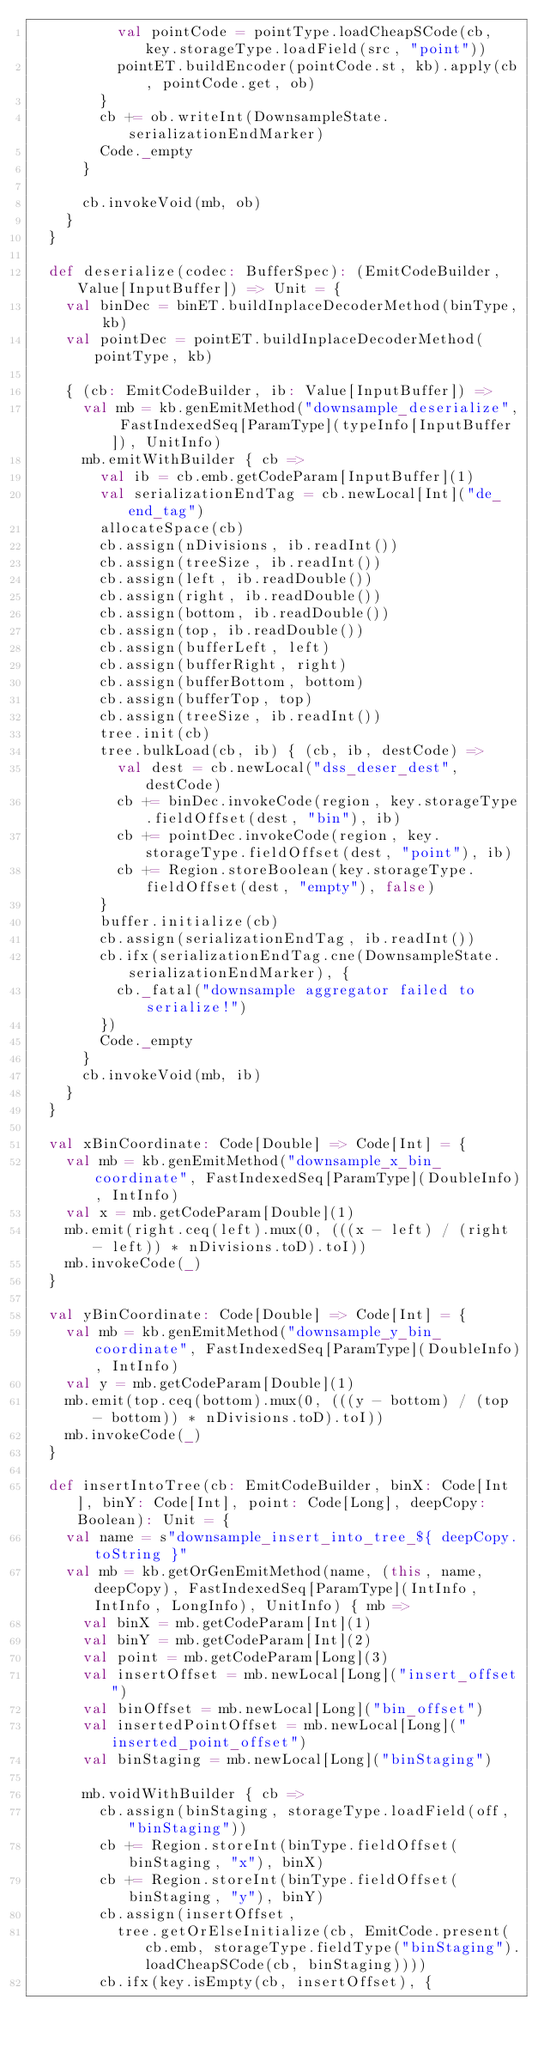<code> <loc_0><loc_0><loc_500><loc_500><_Scala_>          val pointCode = pointType.loadCheapSCode(cb, key.storageType.loadField(src, "point"))
          pointET.buildEncoder(pointCode.st, kb).apply(cb, pointCode.get, ob)
        }
        cb += ob.writeInt(DownsampleState.serializationEndMarker)
        Code._empty
      }

      cb.invokeVoid(mb, ob)
    }
  }

  def deserialize(codec: BufferSpec): (EmitCodeBuilder, Value[InputBuffer]) => Unit = {
    val binDec = binET.buildInplaceDecoderMethod(binType, kb)
    val pointDec = pointET.buildInplaceDecoderMethod(pointType, kb)

    { (cb: EmitCodeBuilder, ib: Value[InputBuffer]) =>
      val mb = kb.genEmitMethod("downsample_deserialize", FastIndexedSeq[ParamType](typeInfo[InputBuffer]), UnitInfo)
      mb.emitWithBuilder { cb =>
        val ib = cb.emb.getCodeParam[InputBuffer](1)
        val serializationEndTag = cb.newLocal[Int]("de_end_tag")
        allocateSpace(cb)
        cb.assign(nDivisions, ib.readInt())
        cb.assign(treeSize, ib.readInt())
        cb.assign(left, ib.readDouble())
        cb.assign(right, ib.readDouble())
        cb.assign(bottom, ib.readDouble())
        cb.assign(top, ib.readDouble())
        cb.assign(bufferLeft, left)
        cb.assign(bufferRight, right)
        cb.assign(bufferBottom, bottom)
        cb.assign(bufferTop, top)
        cb.assign(treeSize, ib.readInt())
        tree.init(cb)
        tree.bulkLoad(cb, ib) { (cb, ib, destCode) =>
          val dest = cb.newLocal("dss_deser_dest", destCode)
          cb += binDec.invokeCode(region, key.storageType.fieldOffset(dest, "bin"), ib)
          cb += pointDec.invokeCode(region, key.storageType.fieldOffset(dest, "point"), ib)
          cb += Region.storeBoolean(key.storageType.fieldOffset(dest, "empty"), false)
        }
        buffer.initialize(cb)
        cb.assign(serializationEndTag, ib.readInt())
        cb.ifx(serializationEndTag.cne(DownsampleState.serializationEndMarker), {
          cb._fatal("downsample aggregator failed to serialize!")
        })
        Code._empty
      }
      cb.invokeVoid(mb, ib)
    }
  }

  val xBinCoordinate: Code[Double] => Code[Int] = {
    val mb = kb.genEmitMethod("downsample_x_bin_coordinate", FastIndexedSeq[ParamType](DoubleInfo), IntInfo)
    val x = mb.getCodeParam[Double](1)
    mb.emit(right.ceq(left).mux(0, (((x - left) / (right - left)) * nDivisions.toD).toI))
    mb.invokeCode(_)
  }

  val yBinCoordinate: Code[Double] => Code[Int] = {
    val mb = kb.genEmitMethod("downsample_y_bin_coordinate", FastIndexedSeq[ParamType](DoubleInfo), IntInfo)
    val y = mb.getCodeParam[Double](1)
    mb.emit(top.ceq(bottom).mux(0, (((y - bottom) / (top - bottom)) * nDivisions.toD).toI))
    mb.invokeCode(_)
  }

  def insertIntoTree(cb: EmitCodeBuilder, binX: Code[Int], binY: Code[Int], point: Code[Long], deepCopy: Boolean): Unit = {
    val name = s"downsample_insert_into_tree_${ deepCopy.toString }"
    val mb = kb.getOrGenEmitMethod(name, (this, name, deepCopy), FastIndexedSeq[ParamType](IntInfo, IntInfo, LongInfo), UnitInfo) { mb =>
      val binX = mb.getCodeParam[Int](1)
      val binY = mb.getCodeParam[Int](2)
      val point = mb.getCodeParam[Long](3)
      val insertOffset = mb.newLocal[Long]("insert_offset")
      val binOffset = mb.newLocal[Long]("bin_offset")
      val insertedPointOffset = mb.newLocal[Long]("inserted_point_offset")
      val binStaging = mb.newLocal[Long]("binStaging")

      mb.voidWithBuilder { cb =>
        cb.assign(binStaging, storageType.loadField(off, "binStaging"))
        cb += Region.storeInt(binType.fieldOffset(binStaging, "x"), binX)
        cb += Region.storeInt(binType.fieldOffset(binStaging, "y"), binY)
        cb.assign(insertOffset,
          tree.getOrElseInitialize(cb, EmitCode.present(cb.emb, storageType.fieldType("binStaging").loadCheapSCode(cb, binStaging))))
        cb.ifx(key.isEmpty(cb, insertOffset), {</code> 